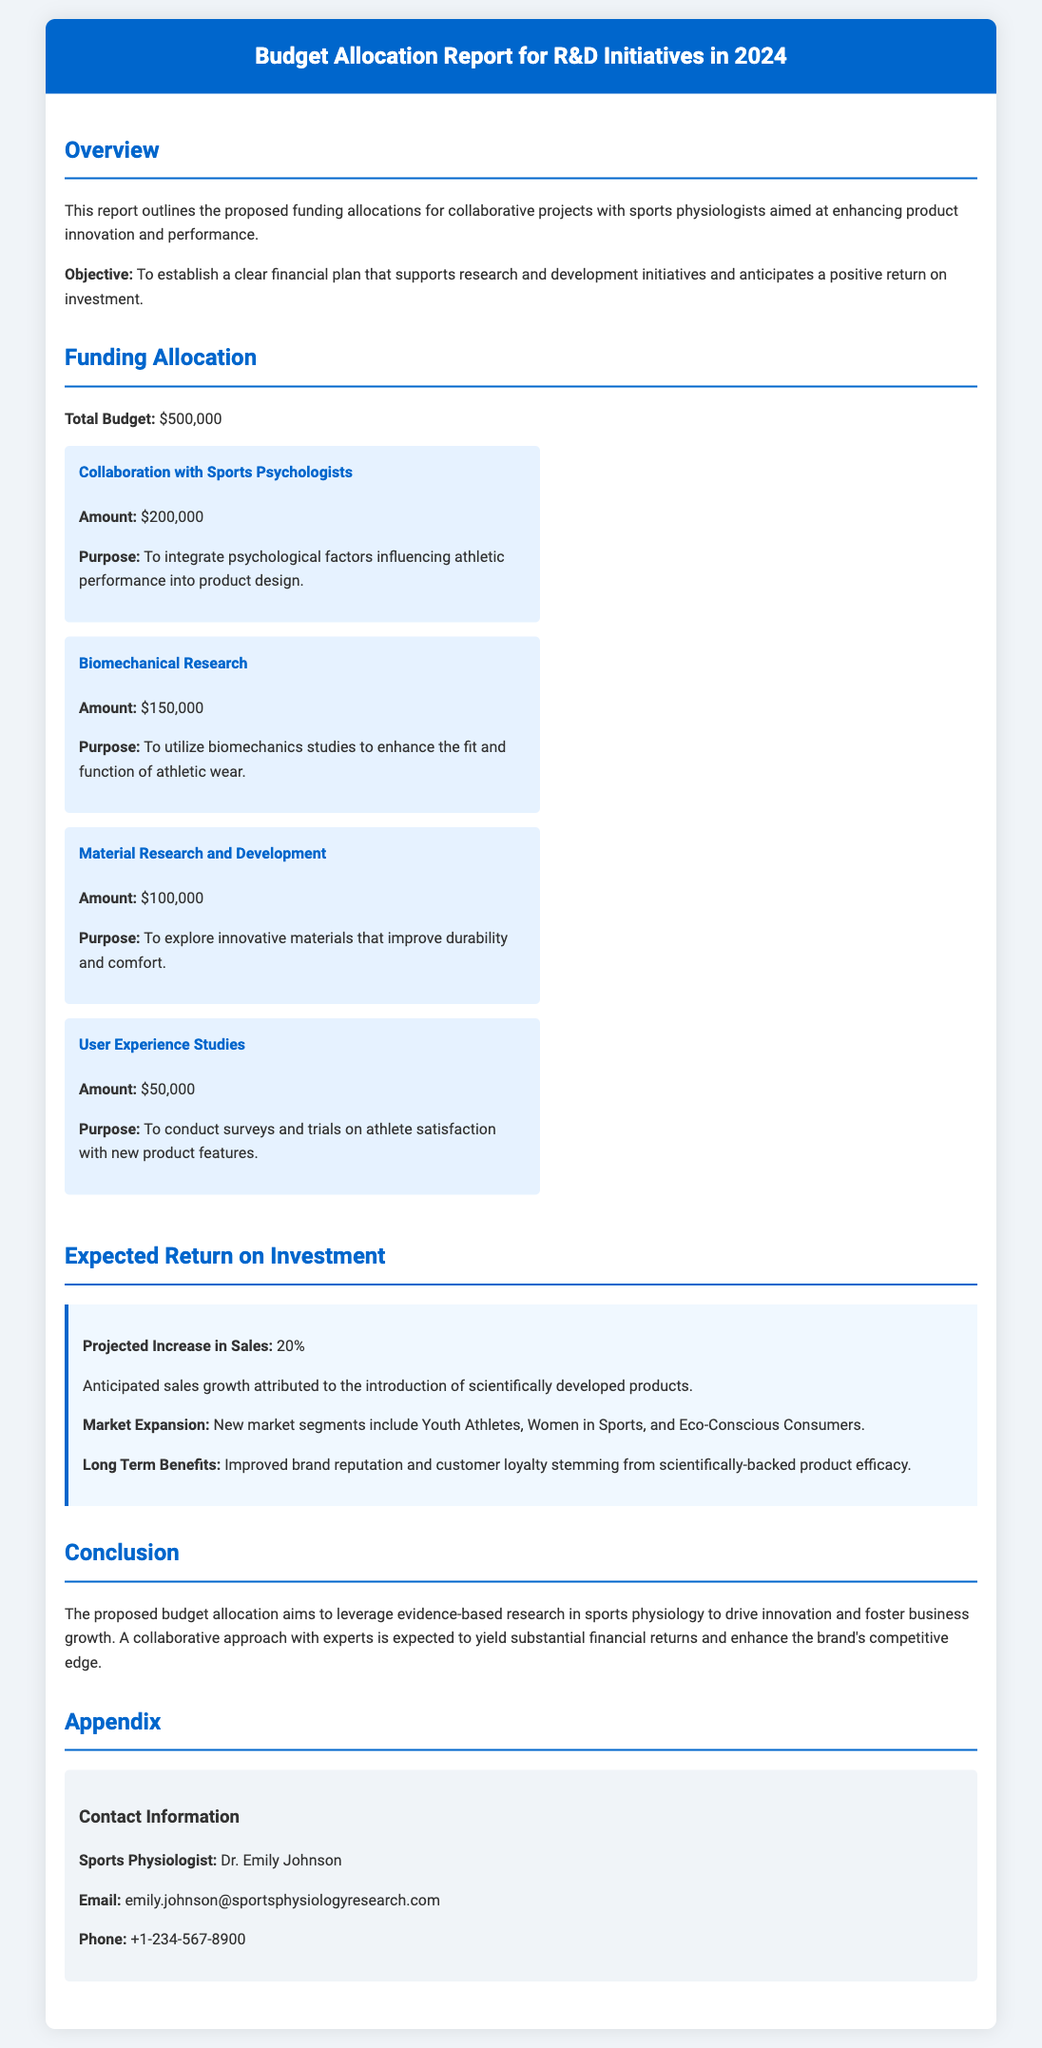What is the total budget for R&D initiatives in 2024? The total budget is stated clearly in the funding allocation section of the document.
Answer: $500,000 How much funding is allocated for collaboration with sports psychologists? The funding allocation section includes specific amounts for each initiative.
Answer: $200,000 What is the purpose of the biomechanical research funding? The purpose is outlined in the funding allocation section under biomechanics.
Answer: To utilize biomechanics studies to enhance the fit and function of athletic wear What is the projected increase in sales expected from the initiatives? The expected return on investment section mentions this projected increase.
Answer: 20% Who is the contact person for sports physiology collaboration? The appendix section lists contact information for collaboration.
Answer: Dr. Emily Johnson Which new market segments are anticipated for expansion? The expected return on investment section discusses this detail.
Answer: Youth Athletes, Women in Sports, and Eco-Conscious Consumers 